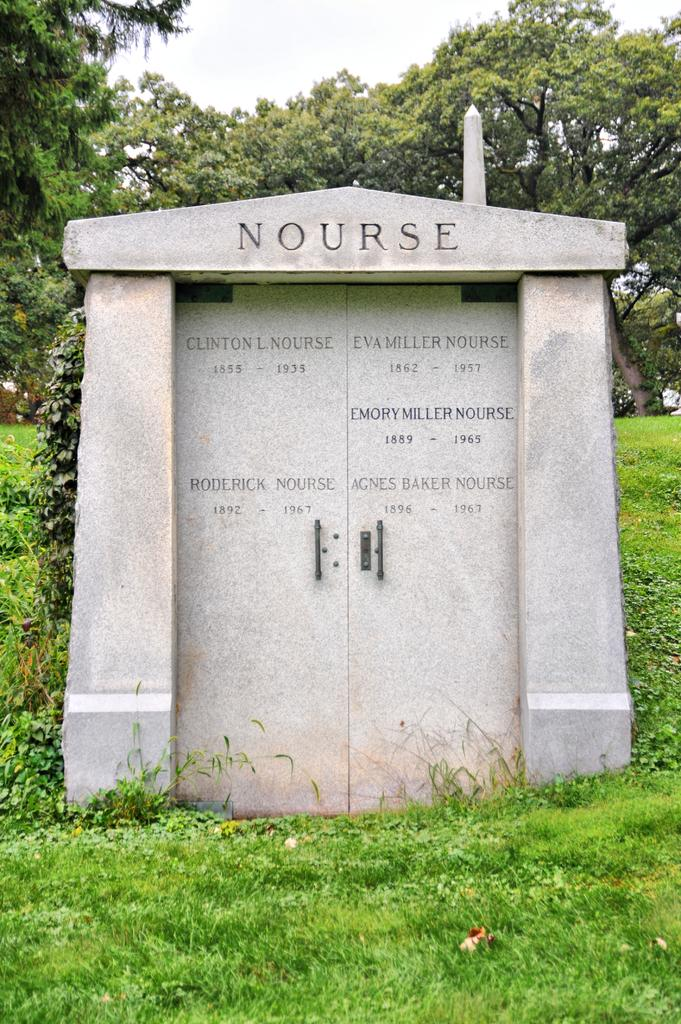What is the main object in the image? There is a gravestone in the image. What type of vegetation is present in the image? Grass, plants, and trees are present in the image. What can be seen in the background of the image? The sky is visible in the background of the image. What type of tomatoes are growing on the gravestone in the image? There are no tomatoes present in the image, and they are not growing on the gravestone. 